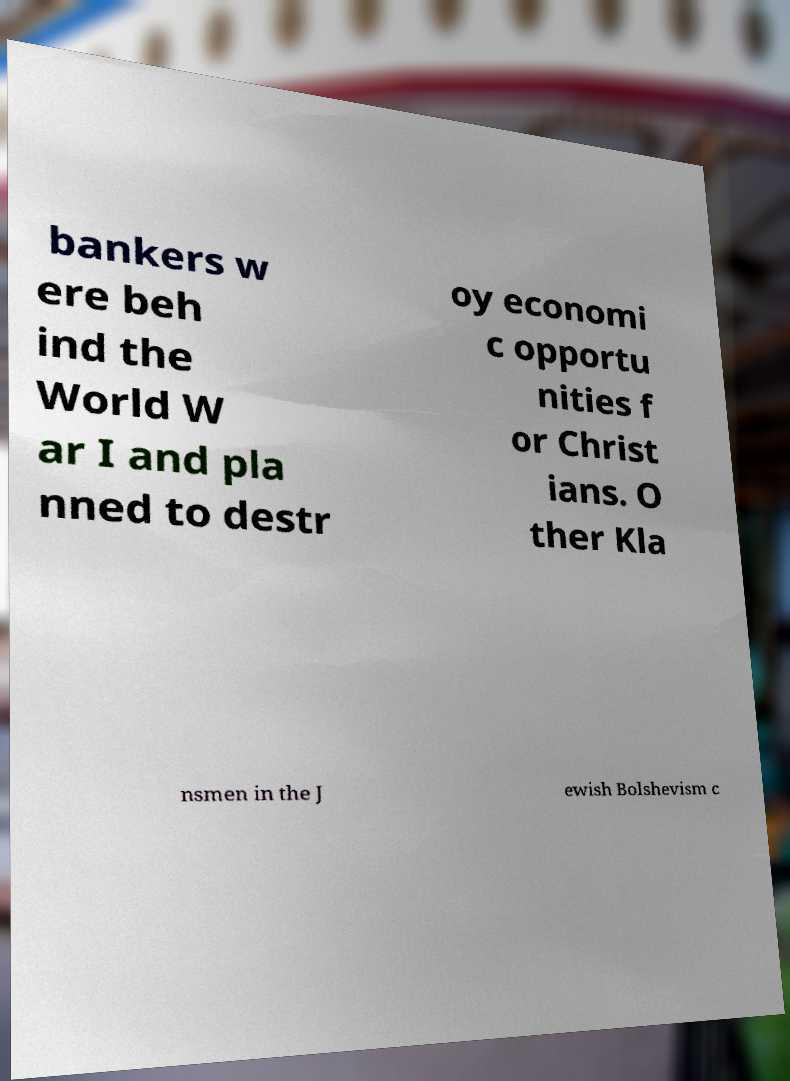I need the written content from this picture converted into text. Can you do that? bankers w ere beh ind the World W ar I and pla nned to destr oy economi c opportu nities f or Christ ians. O ther Kla nsmen in the J ewish Bolshevism c 